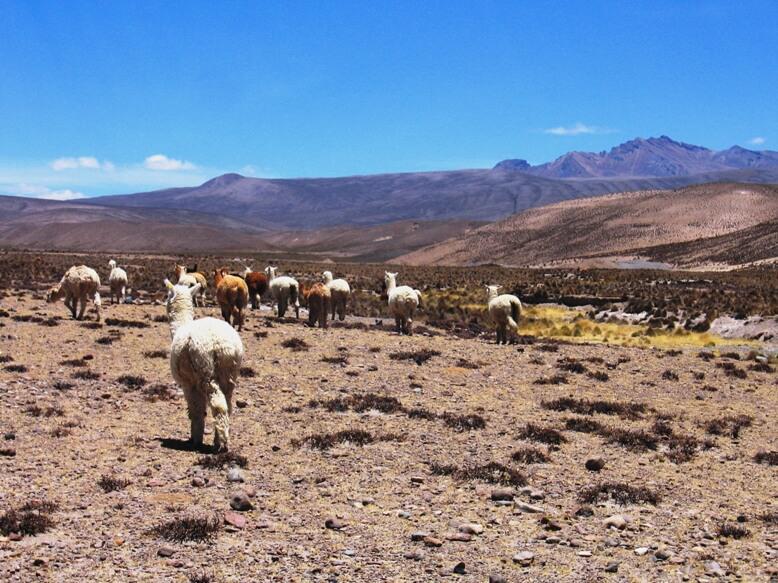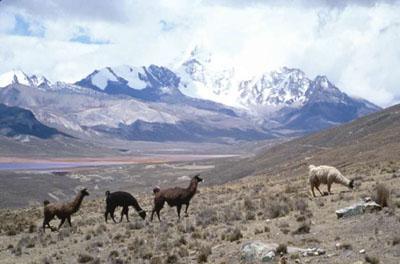The first image is the image on the left, the second image is the image on the right. Assess this claim about the two images: "The right image shows a line of rightward facing llamas standing on ground with sparse foliage and mountain peaks in the background.". Correct or not? Answer yes or no. Yes. The first image is the image on the left, the second image is the image on the right. Evaluate the accuracy of this statement regarding the images: "In the right image, fewer than ten llamas wander through grass scrubs, and a snow covered mountain is in the background.". Is it true? Answer yes or no. Yes. 